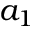Convert formula to latex. <formula><loc_0><loc_0><loc_500><loc_500>a _ { 1 }</formula> 